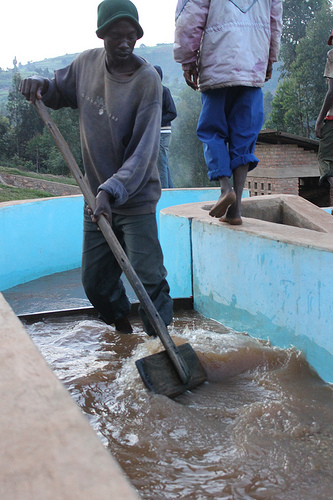<image>
Is the man in the water? Yes. The man is contained within or inside the water, showing a containment relationship. 